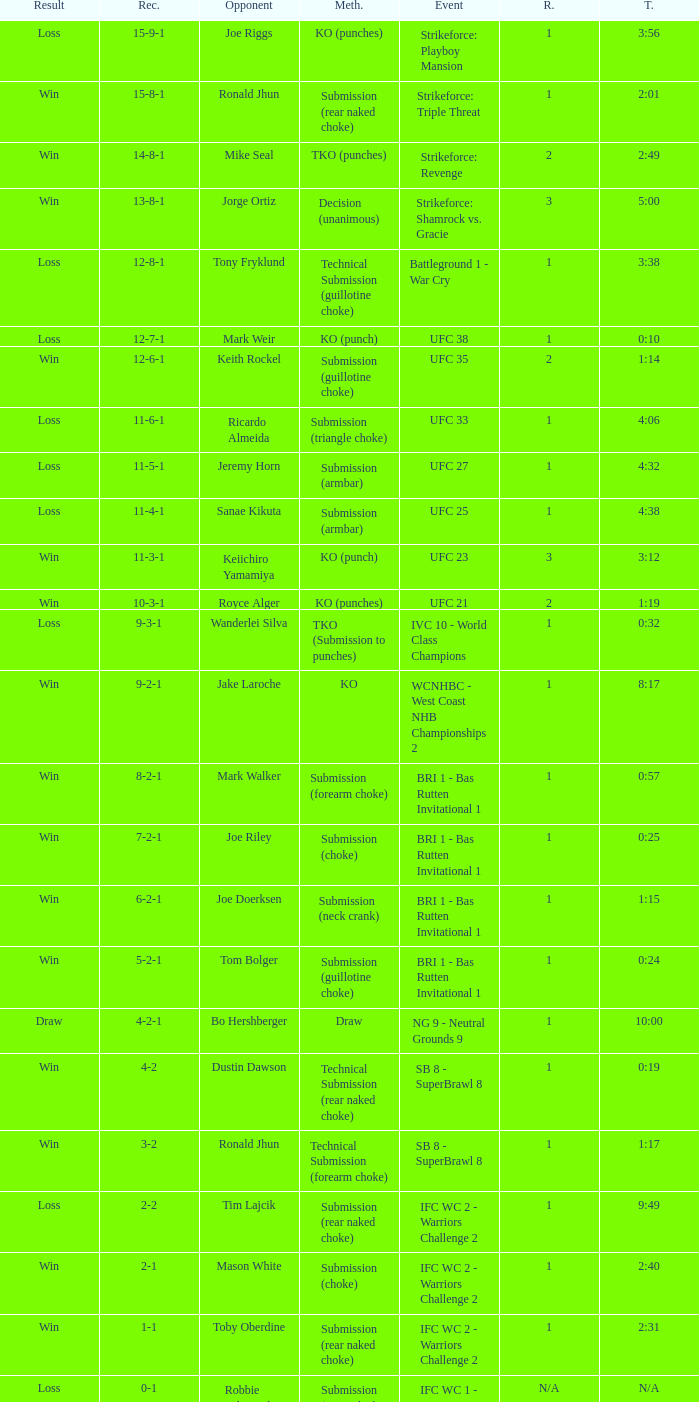What was the outcome when the resolution method involved a knockout? 9-2-1. 